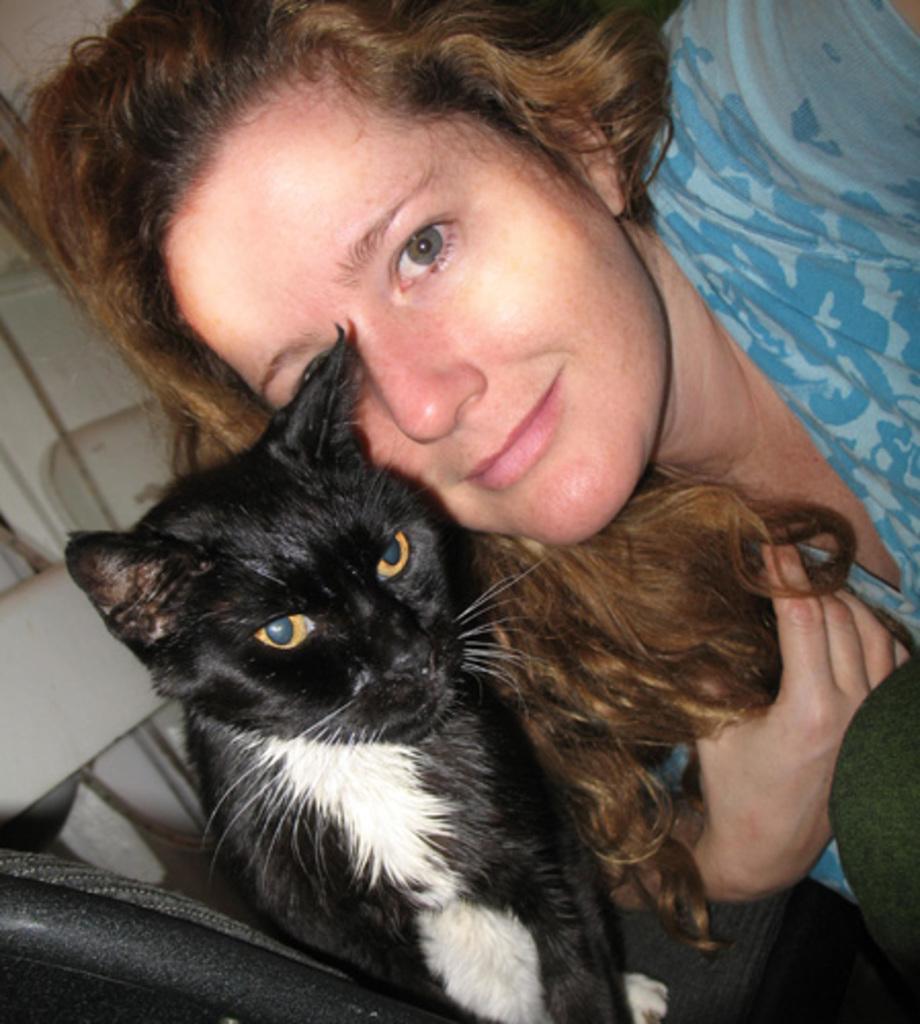In one or two sentences, can you explain what this image depicts? In this picture we can see women wearing a blue dress is holding a black and white hair cat, with yellow color eye and white whiskers. 